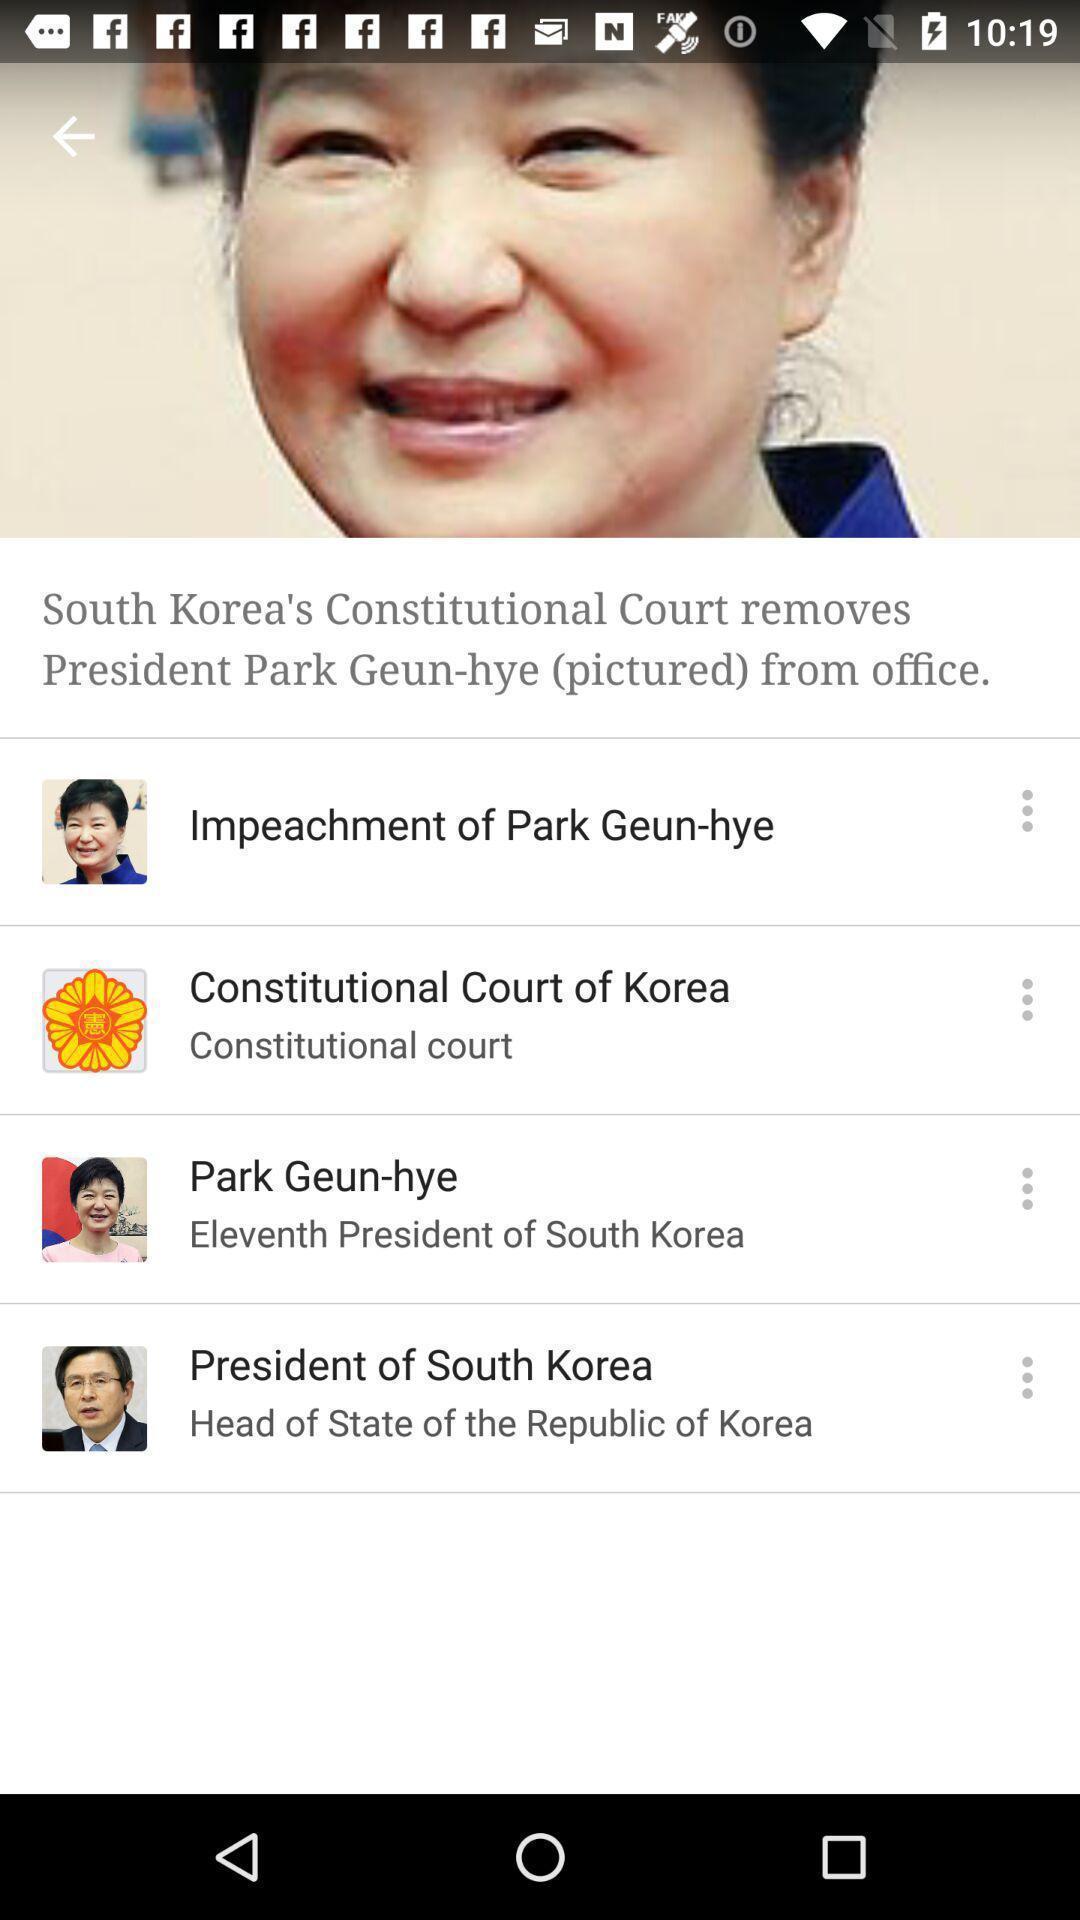What is the overall content of this screenshot? Various news tabs in the application. 